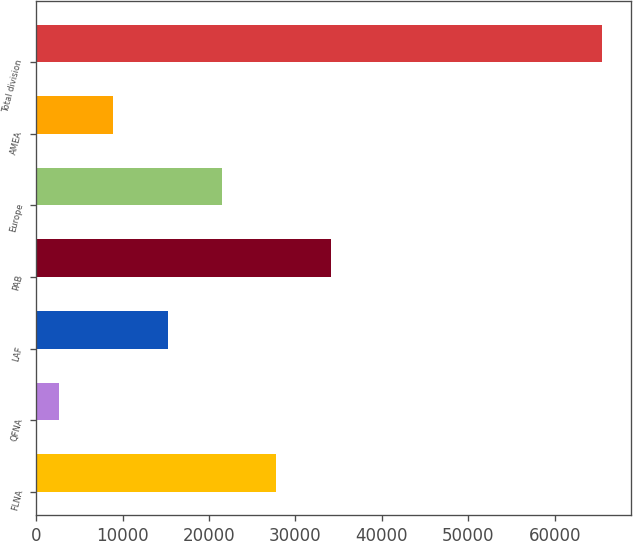Convert chart to OTSL. <chart><loc_0><loc_0><loc_500><loc_500><bar_chart><fcel>FLNA<fcel>QFNA<fcel>LAF<fcel>PAB<fcel>Europe<fcel>AMEA<fcel>Total division<nl><fcel>27778.4<fcel>2636<fcel>15207.2<fcel>34064<fcel>21492.8<fcel>8921.6<fcel>65492<nl></chart> 